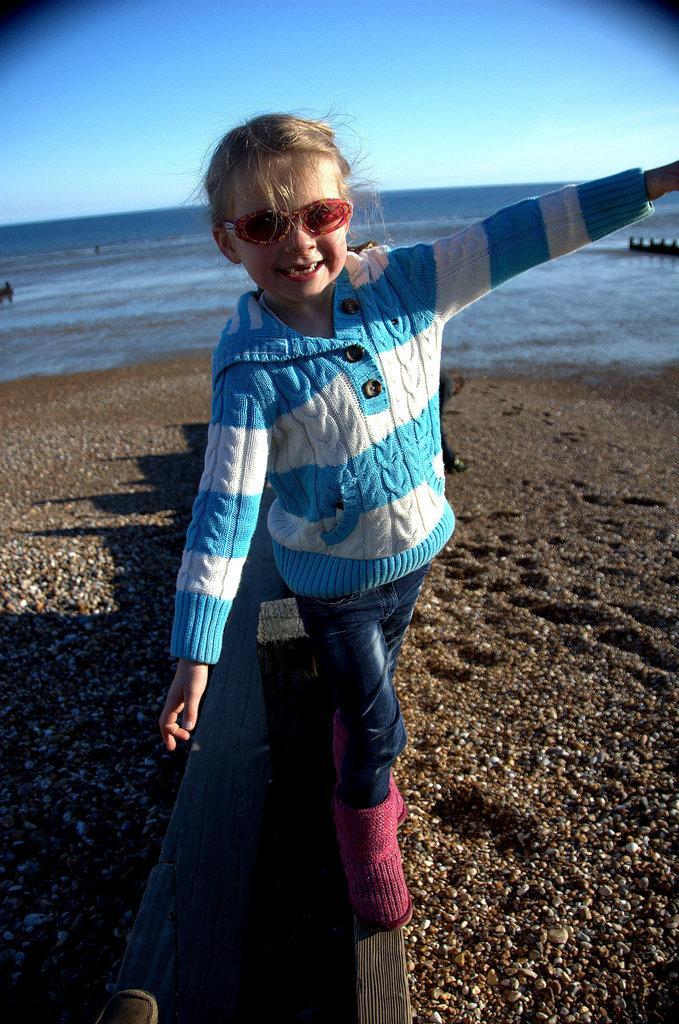Can you describe this image briefly? In this image there is the sky towards the top of the image, there is water, there is sand towards the bottom of the image, there is a wooden object towards the bottom of the image, there is a girl, she is wearing goggles. 